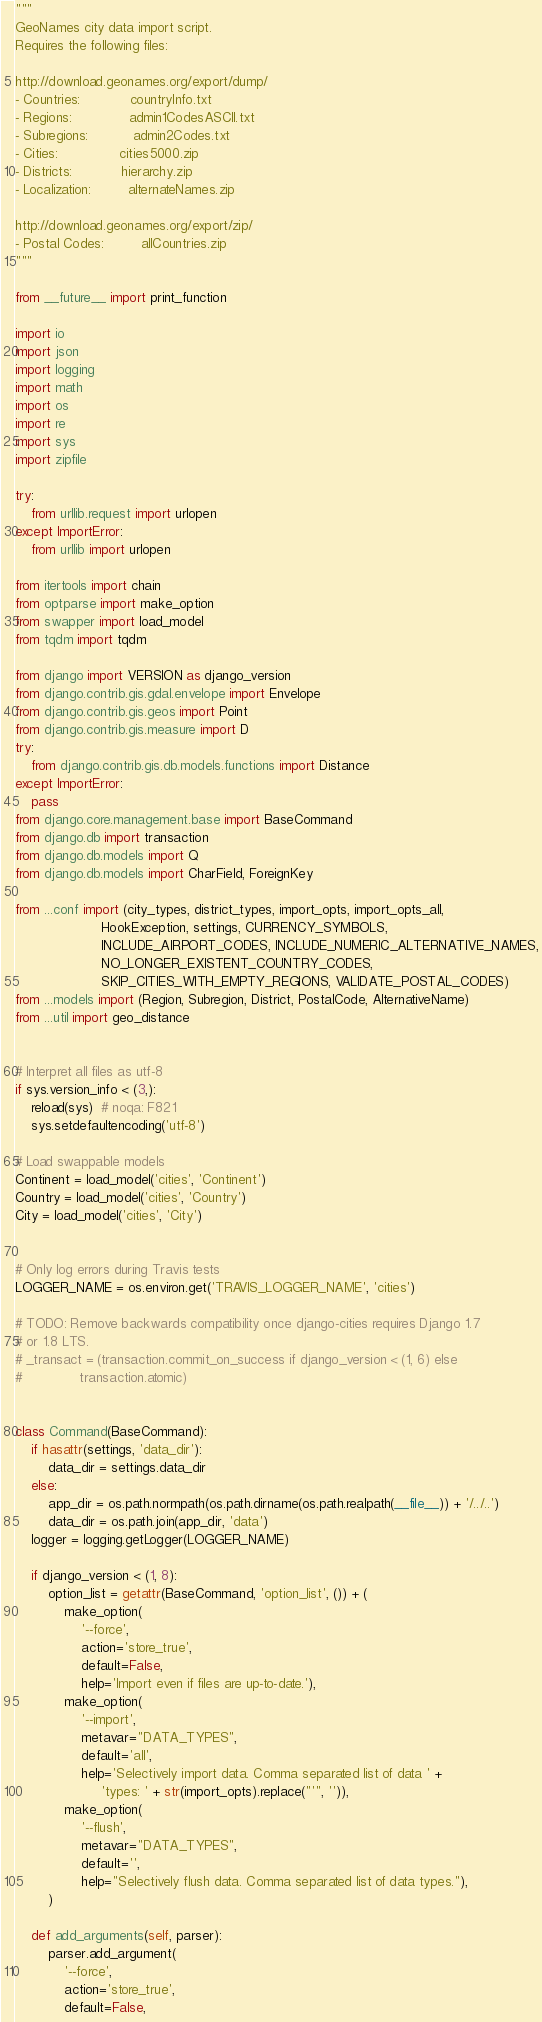<code> <loc_0><loc_0><loc_500><loc_500><_Python_>"""
GeoNames city data import script.
Requires the following files:

http://download.geonames.org/export/dump/
- Countries:            countryInfo.txt
- Regions:              admin1CodesASCII.txt
- Subregions:           admin2Codes.txt
- Cities:               cities5000.zip
- Districts:            hierarchy.zip
- Localization:         alternateNames.zip

http://download.geonames.org/export/zip/
- Postal Codes:         allCountries.zip
"""

from __future__ import print_function

import io
import json
import logging
import math
import os
import re
import sys
import zipfile

try:
    from urllib.request import urlopen
except ImportError:
    from urllib import urlopen

from itertools import chain
from optparse import make_option
from swapper import load_model
from tqdm import tqdm

from django import VERSION as django_version
from django.contrib.gis.gdal.envelope import Envelope
from django.contrib.gis.geos import Point
from django.contrib.gis.measure import D
try:
    from django.contrib.gis.db.models.functions import Distance
except ImportError:
    pass
from django.core.management.base import BaseCommand
from django.db import transaction
from django.db.models import Q
from django.db.models import CharField, ForeignKey

from ...conf import (city_types, district_types, import_opts, import_opts_all,
                     HookException, settings, CURRENCY_SYMBOLS,
                     INCLUDE_AIRPORT_CODES, INCLUDE_NUMERIC_ALTERNATIVE_NAMES,
                     NO_LONGER_EXISTENT_COUNTRY_CODES,
                     SKIP_CITIES_WITH_EMPTY_REGIONS, VALIDATE_POSTAL_CODES)
from ...models import (Region, Subregion, District, PostalCode, AlternativeName)
from ...util import geo_distance


# Interpret all files as utf-8
if sys.version_info < (3,):
    reload(sys)  # noqa: F821
    sys.setdefaultencoding('utf-8')

# Load swappable models
Continent = load_model('cities', 'Continent')
Country = load_model('cities', 'Country')
City = load_model('cities', 'City')


# Only log errors during Travis tests
LOGGER_NAME = os.environ.get('TRAVIS_LOGGER_NAME', 'cities')

# TODO: Remove backwards compatibility once django-cities requires Django 1.7
# or 1.8 LTS.
# _transact = (transaction.commit_on_success if django_version < (1, 6) else
#              transaction.atomic)


class Command(BaseCommand):
    if hasattr(settings, 'data_dir'):
        data_dir = settings.data_dir
    else:
        app_dir = os.path.normpath(os.path.dirname(os.path.realpath(__file__)) + '/../..')
        data_dir = os.path.join(app_dir, 'data')
    logger = logging.getLogger(LOGGER_NAME)

    if django_version < (1, 8):
        option_list = getattr(BaseCommand, 'option_list', ()) + (
            make_option(
                '--force',
                action='store_true',
                default=False,
                help='Import even if files are up-to-date.'),
            make_option(
                '--import',
                metavar="DATA_TYPES",
                default='all',
                help='Selectively import data. Comma separated list of data ' +
                     'types: ' + str(import_opts).replace("'", '')),
            make_option(
                '--flush',
                metavar="DATA_TYPES",
                default='',
                help="Selectively flush data. Comma separated list of data types."),
        )

    def add_arguments(self, parser):
        parser.add_argument(
            '--force',
            action='store_true',
            default=False,</code> 